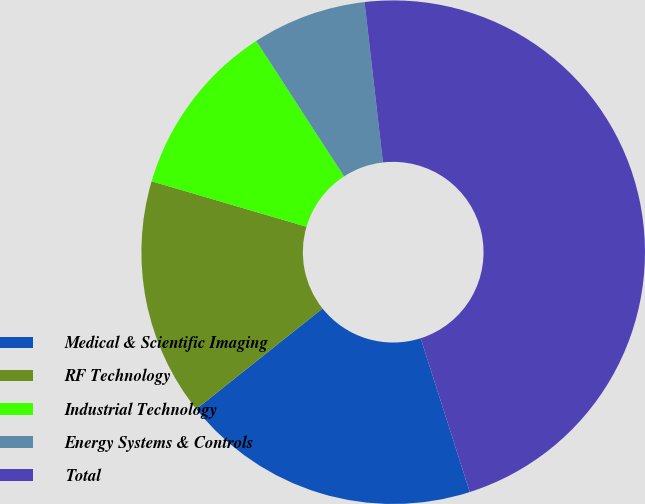Convert chart to OTSL. <chart><loc_0><loc_0><loc_500><loc_500><pie_chart><fcel>Medical & Scientific Imaging<fcel>RF Technology<fcel>Industrial Technology<fcel>Energy Systems & Controls<fcel>Total<nl><fcel>19.21%<fcel>15.25%<fcel>11.3%<fcel>7.34%<fcel>46.89%<nl></chart> 